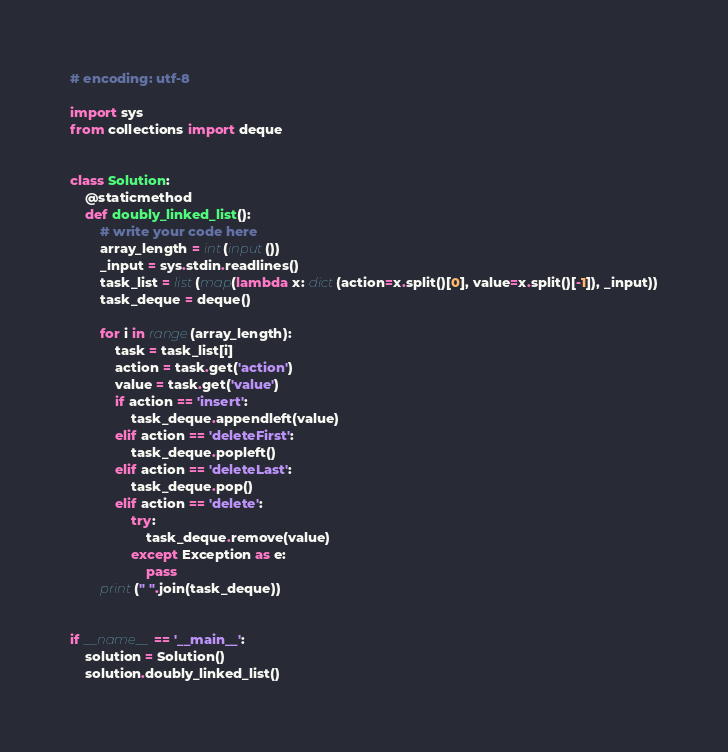Convert code to text. <code><loc_0><loc_0><loc_500><loc_500><_Python_># encoding: utf-8

import sys
from collections import deque


class Solution:
    @staticmethod
    def doubly_linked_list():
        # write your code here
        array_length = int(input())
        _input = sys.stdin.readlines()
        task_list = list(map(lambda x: dict(action=x.split()[0], value=x.split()[-1]), _input))
        task_deque = deque()

        for i in range(array_length):
            task = task_list[i]
            action = task.get('action')
            value = task.get('value')
            if action == 'insert':
                task_deque.appendleft(value)
            elif action == 'deleteFirst':
                task_deque.popleft()
            elif action == 'deleteLast':
                task_deque.pop()
            elif action == 'delete':
                try:
                    task_deque.remove(value)
                except Exception as e:
                    pass
        print(" ".join(task_deque))


if __name__ == '__main__':
    solution = Solution()
    solution.doubly_linked_list()</code> 